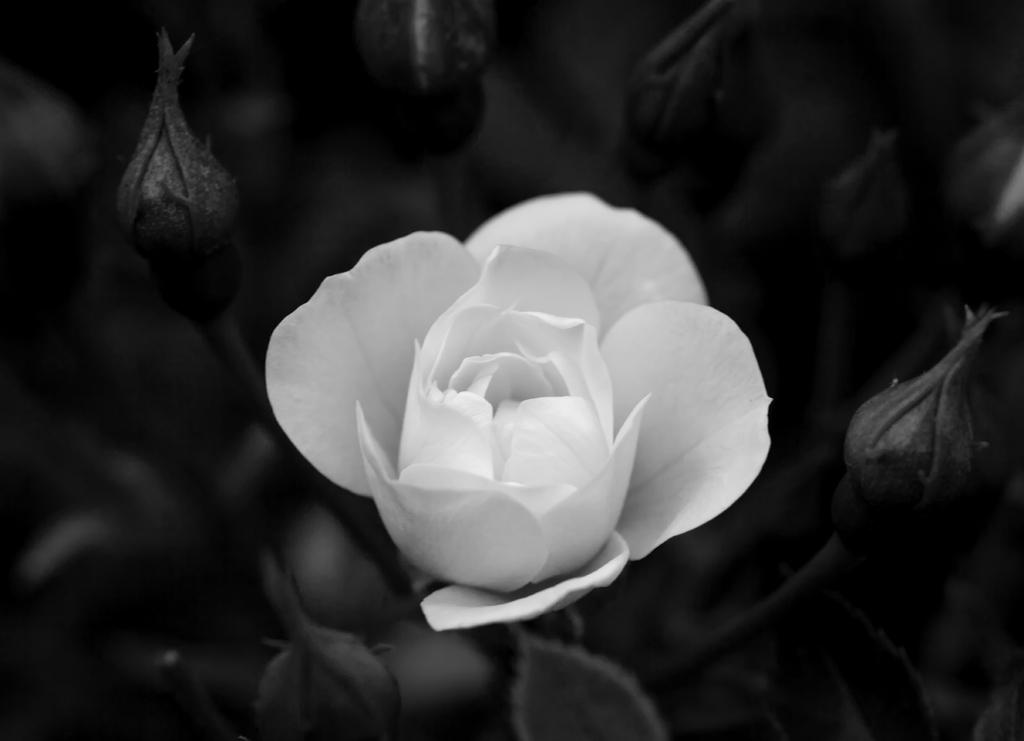What is the color scheme of the image? The image is black and white. What is the main subject in the center of the image? There is a rose in the center of the image. What can be seen around the main subject? There are buds around the rose. How would you describe the background of the image? The background of the image is blurry. Are there any visible icicles hanging from the rose in the image? No, there are no icicles present in the image. 